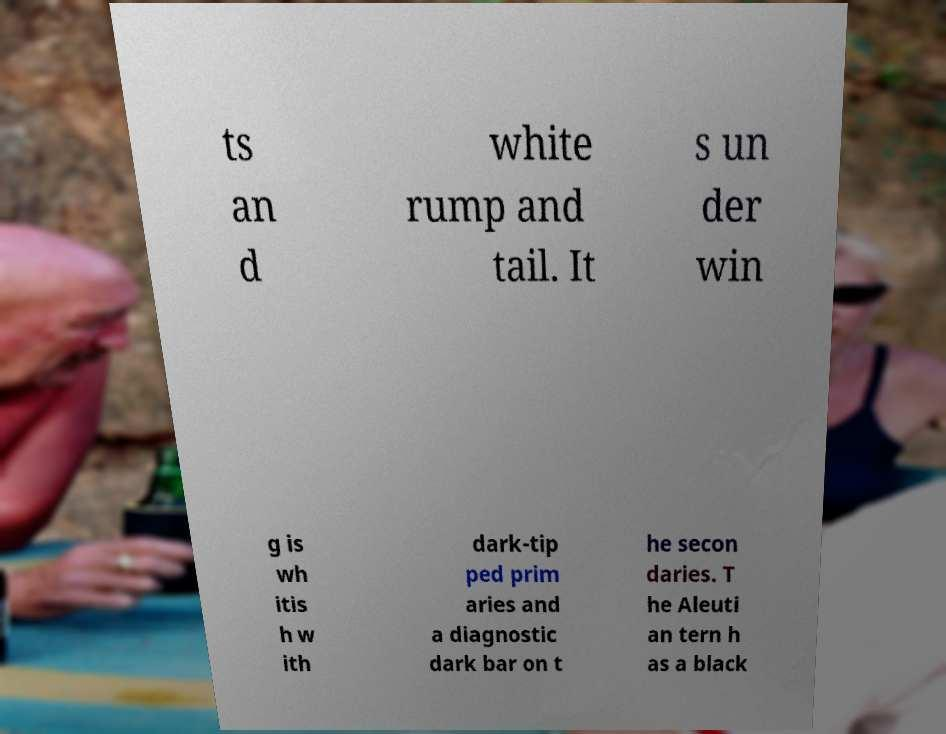Can you read and provide the text displayed in the image?This photo seems to have some interesting text. Can you extract and type it out for me? ts an d white rump and tail. It s un der win g is wh itis h w ith dark-tip ped prim aries and a diagnostic dark bar on t he secon daries. T he Aleuti an tern h as a black 